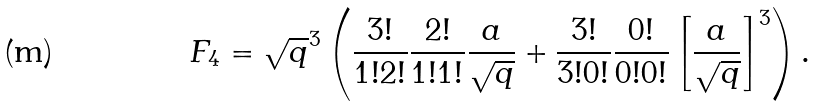Convert formula to latex. <formula><loc_0><loc_0><loc_500><loc_500>F _ { 4 } = \sqrt { q } ^ { 3 } \left ( \frac { 3 ! } { 1 ! 2 ! } \frac { 2 ! } { 1 ! 1 ! } \frac { a } { \sqrt { q } } + \frac { 3 ! } { 3 ! 0 ! } \frac { 0 ! } { 0 ! 0 ! } \left [ \frac { a } { \sqrt { q } } \right ] ^ { 3 } \right ) .</formula> 